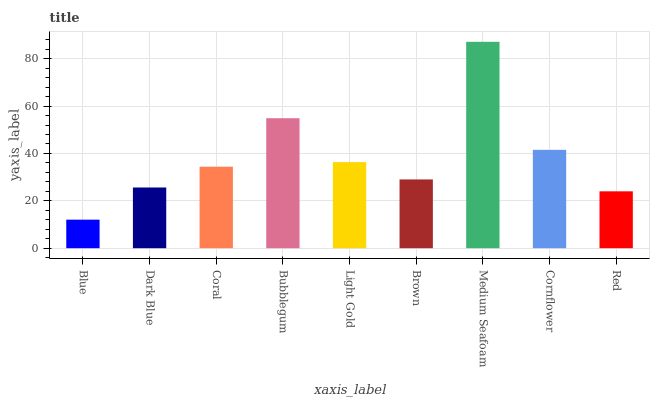Is Blue the minimum?
Answer yes or no. Yes. Is Medium Seafoam the maximum?
Answer yes or no. Yes. Is Dark Blue the minimum?
Answer yes or no. No. Is Dark Blue the maximum?
Answer yes or no. No. Is Dark Blue greater than Blue?
Answer yes or no. Yes. Is Blue less than Dark Blue?
Answer yes or no. Yes. Is Blue greater than Dark Blue?
Answer yes or no. No. Is Dark Blue less than Blue?
Answer yes or no. No. Is Coral the high median?
Answer yes or no. Yes. Is Coral the low median?
Answer yes or no. Yes. Is Blue the high median?
Answer yes or no. No. Is Light Gold the low median?
Answer yes or no. No. 